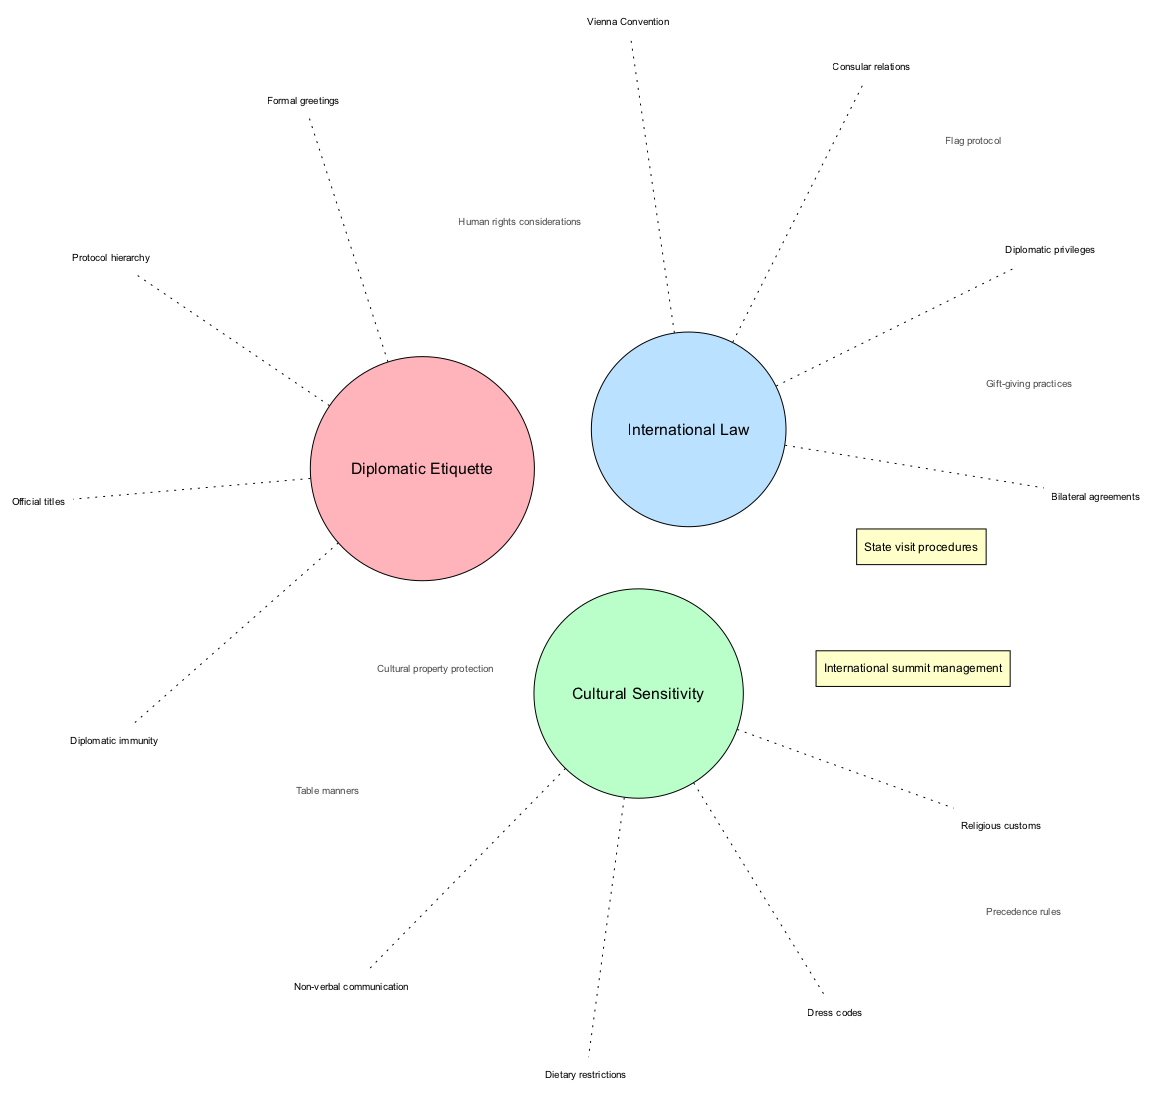What are the elements under Diplomatic Etiquette? The diagram lists four elements under Diplomatic Etiquette: Protocol hierarchy, Formal greetings, Official titles, and Diplomatic immunity. These are directly represented as branches connected to the Diplomatic Etiquette circle.
Answer: Protocol hierarchy, Formal greetings, Official titles, Diplomatic immunity How many elements are in the Cultural Sensitivity circle? The Cultural Sensitivity circle contains four elements, which are Religious customs, Non-verbal communication, Dress codes, and Dietary restrictions. This can be counted from the visual representation of the circle.
Answer: 4 What are the elements shared between Sensitivity and Law? The elements in the intersection of Sensitivity and Law are Cultural property protection and Human rights considerations. This intersection is visually indicated as containing these specific elements.
Answer: Cultural property protection, Human rights considerations Which element is included in both Law and Etiquette? The element Flag protocol is listed as belonging to the intersection of Law and Etiquette. It is shown as a part of the overlap between those two circles in the diagram.
Answer: Flag protocol How many main circles are represented in the diagram? There are three main circles depicted in the diagram, representing Diplomatic Etiquette, Cultural Sensitivity, and International Law. This can be visually counted in the diagram.
Answer: 3 What is the central intersection shared by all three categories? The central intersection, where all three categories overlap, contains State visit procedures and International summit management. This is explicitly indicated in the diagram as the intersection.
Answer: State visit procedures, International summit management What do the dashed edges signify in the diagram? The dashed edges connecting the elements to their respective circles signify a non-solid relationship, indicating that these are part of the description or examples related to the main theme of each circle. This communication method visually differentiates the primary concepts from their related elements.
Answer: Non-solid relationship What is the significance of the color coding in the circles? The color coding in the circles serves to visually differentiate between the three categories: Diplomatic Etiquette, Cultural Sensitivity, and International Law. Each color correlates to a specific circle, enhancing clarity and organization in the diagram.
Answer: Visual differentiation How many unique intersections are there in the entire diagram? There are four unique intersections in total, which include two-element overlaps and a central intersection. They specify the shared elements between the main categories.
Answer: 4 